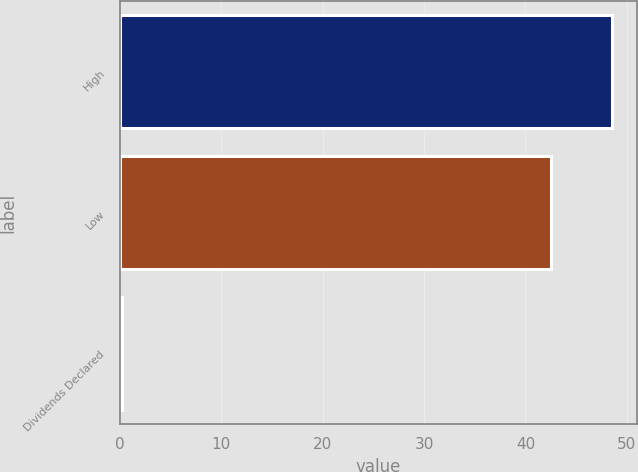Convert chart to OTSL. <chart><loc_0><loc_0><loc_500><loc_500><bar_chart><fcel>High<fcel>Low<fcel>Dividends Declared<nl><fcel>48.58<fcel>42.5<fcel>0.23<nl></chart> 